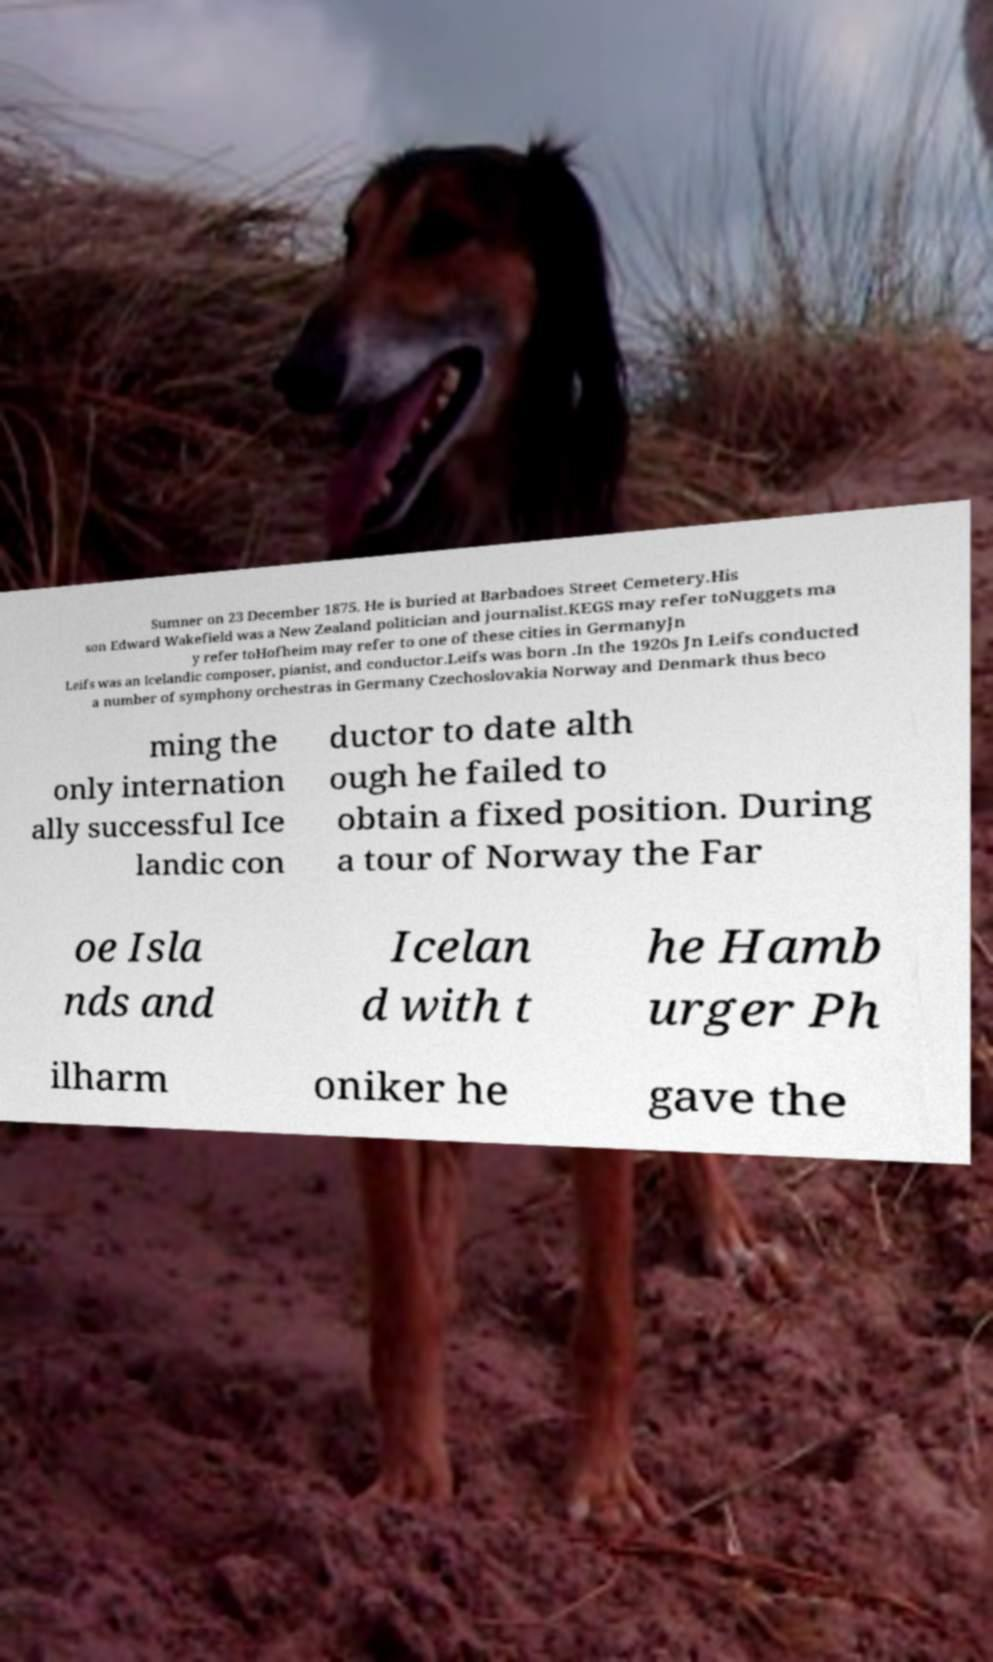I need the written content from this picture converted into text. Can you do that? Sumner on 23 December 1875. He is buried at Barbadoes Street Cemetery.His son Edward Wakefield was a New Zealand politician and journalist.KEGS may refer toNuggets ma y refer toHofheim may refer to one of these cities in GermanyJn Leifs was an Icelandic composer, pianist, and conductor.Leifs was born .In the 1920s Jn Leifs conducted a number of symphony orchestras in Germany Czechoslovakia Norway and Denmark thus beco ming the only internation ally successful Ice landic con ductor to date alth ough he failed to obtain a fixed position. During a tour of Norway the Far oe Isla nds and Icelan d with t he Hamb urger Ph ilharm oniker he gave the 